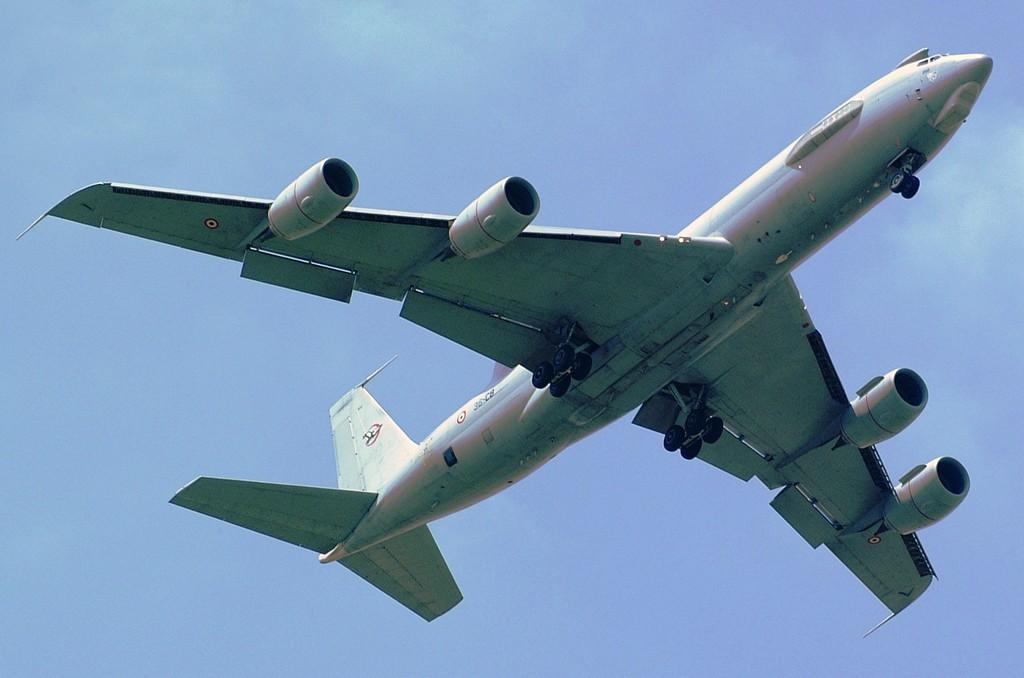What is the main subject of the image? The main subject of the image is an aeroplane. What is the aeroplane doing in the image? The aeroplane is flying in the sky. Can you see the foot of the pilot in the image? There is no pilot or foot visible in the image; it only shows an aeroplane flying in the sky. What type of structure is the aeroplane smiling in the image? There is no structure or smiling expression present in the image; it only shows an aeroplane flying in the sky. 